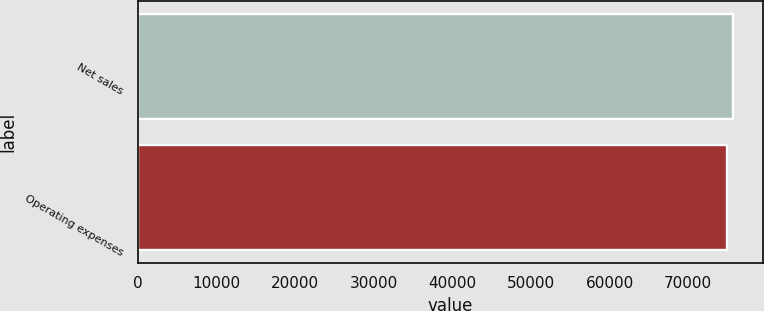Convert chart to OTSL. <chart><loc_0><loc_0><loc_500><loc_500><bar_chart><fcel>Net sales<fcel>Operating expenses<nl><fcel>75736<fcel>74962<nl></chart> 